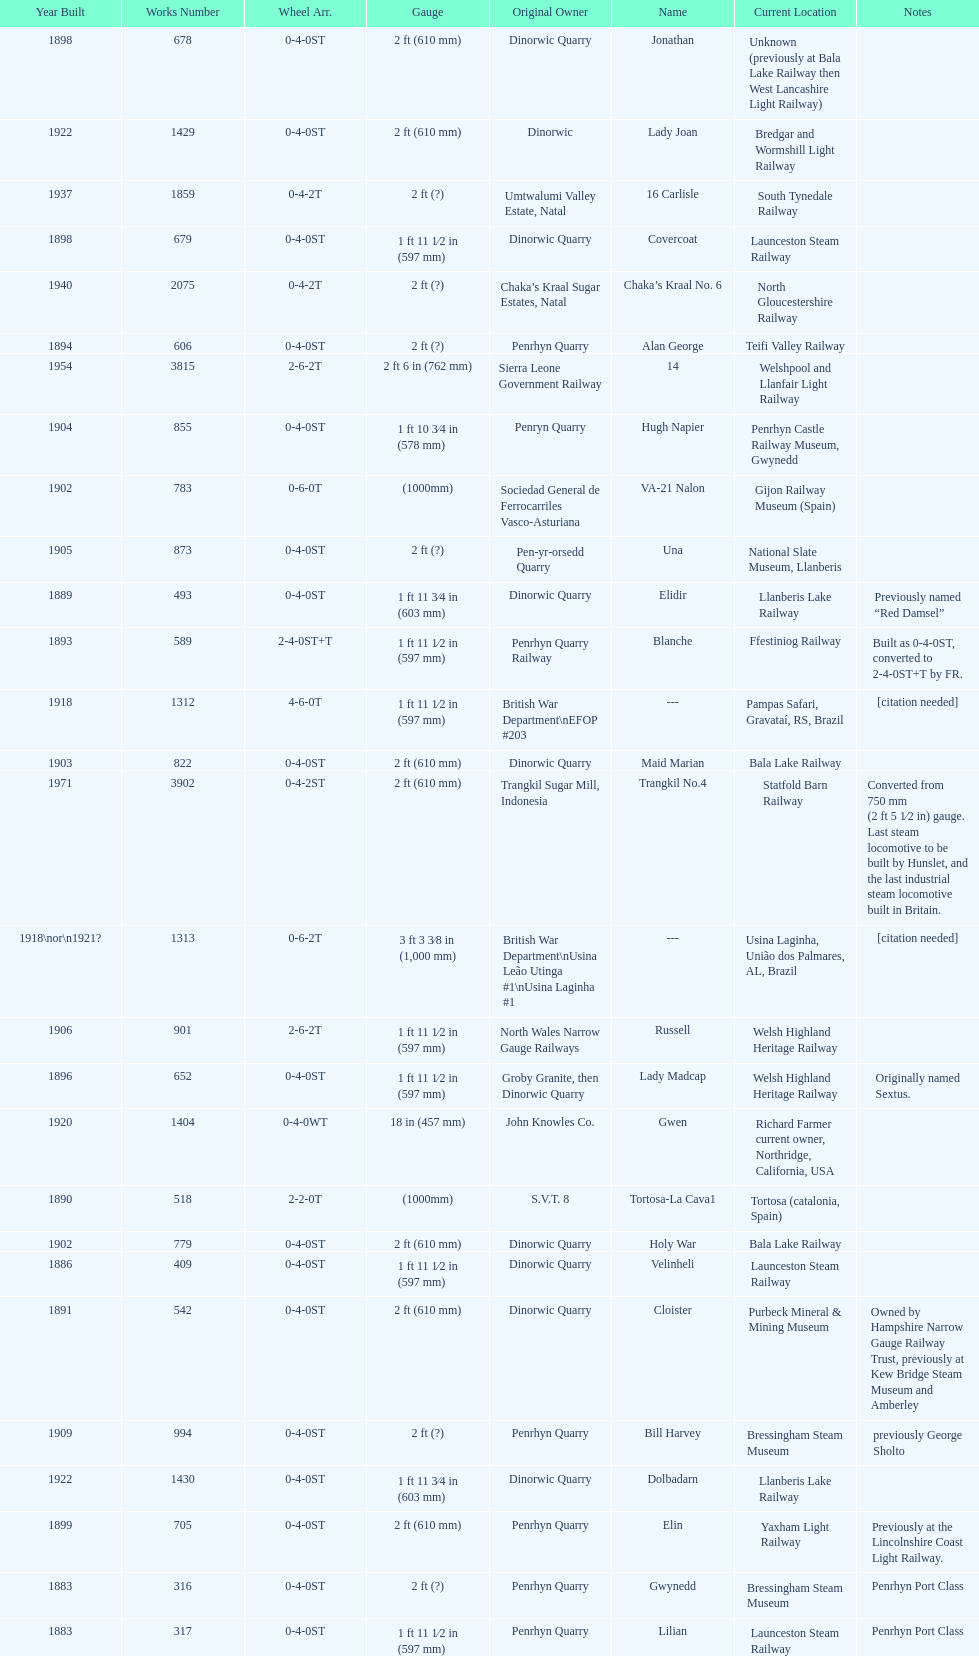Which original owner had the most locomotives? Penrhyn Quarry. 